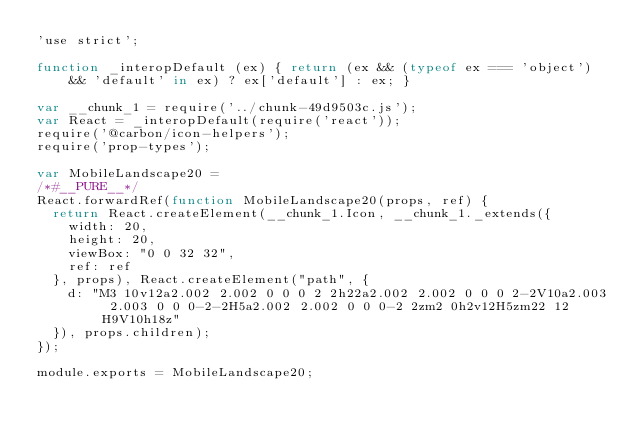Convert code to text. <code><loc_0><loc_0><loc_500><loc_500><_JavaScript_>'use strict';

function _interopDefault (ex) { return (ex && (typeof ex === 'object') && 'default' in ex) ? ex['default'] : ex; }

var __chunk_1 = require('../chunk-49d9503c.js');
var React = _interopDefault(require('react'));
require('@carbon/icon-helpers');
require('prop-types');

var MobileLandscape20 =
/*#__PURE__*/
React.forwardRef(function MobileLandscape20(props, ref) {
  return React.createElement(__chunk_1.Icon, __chunk_1._extends({
    width: 20,
    height: 20,
    viewBox: "0 0 32 32",
    ref: ref
  }, props), React.createElement("path", {
    d: "M3 10v12a2.002 2.002 0 0 0 2 2h22a2.002 2.002 0 0 0 2-2V10a2.003 2.003 0 0 0-2-2H5a2.002 2.002 0 0 0-2 2zm2 0h2v12H5zm22 12H9V10h18z"
  }), props.children);
});

module.exports = MobileLandscape20;
</code> 